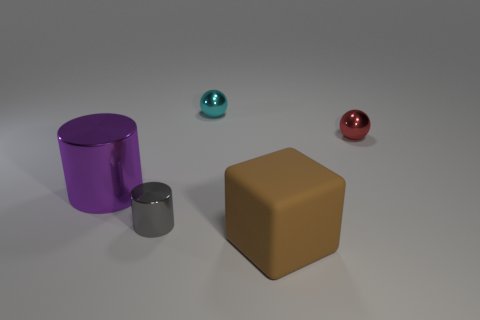Add 3 blue shiny objects. How many objects exist? 8 Subtract 1 cubes. How many cubes are left? 0 Subtract all yellow cylinders. Subtract all yellow cubes. How many cylinders are left? 2 Subtract all cyan cylinders. How many blue balls are left? 0 Subtract all tiny red objects. Subtract all big metal cylinders. How many objects are left? 3 Add 4 big purple metal objects. How many big purple metal objects are left? 5 Add 5 large gray metal cylinders. How many large gray metal cylinders exist? 5 Subtract 0 blue cylinders. How many objects are left? 5 Subtract all cylinders. How many objects are left? 3 